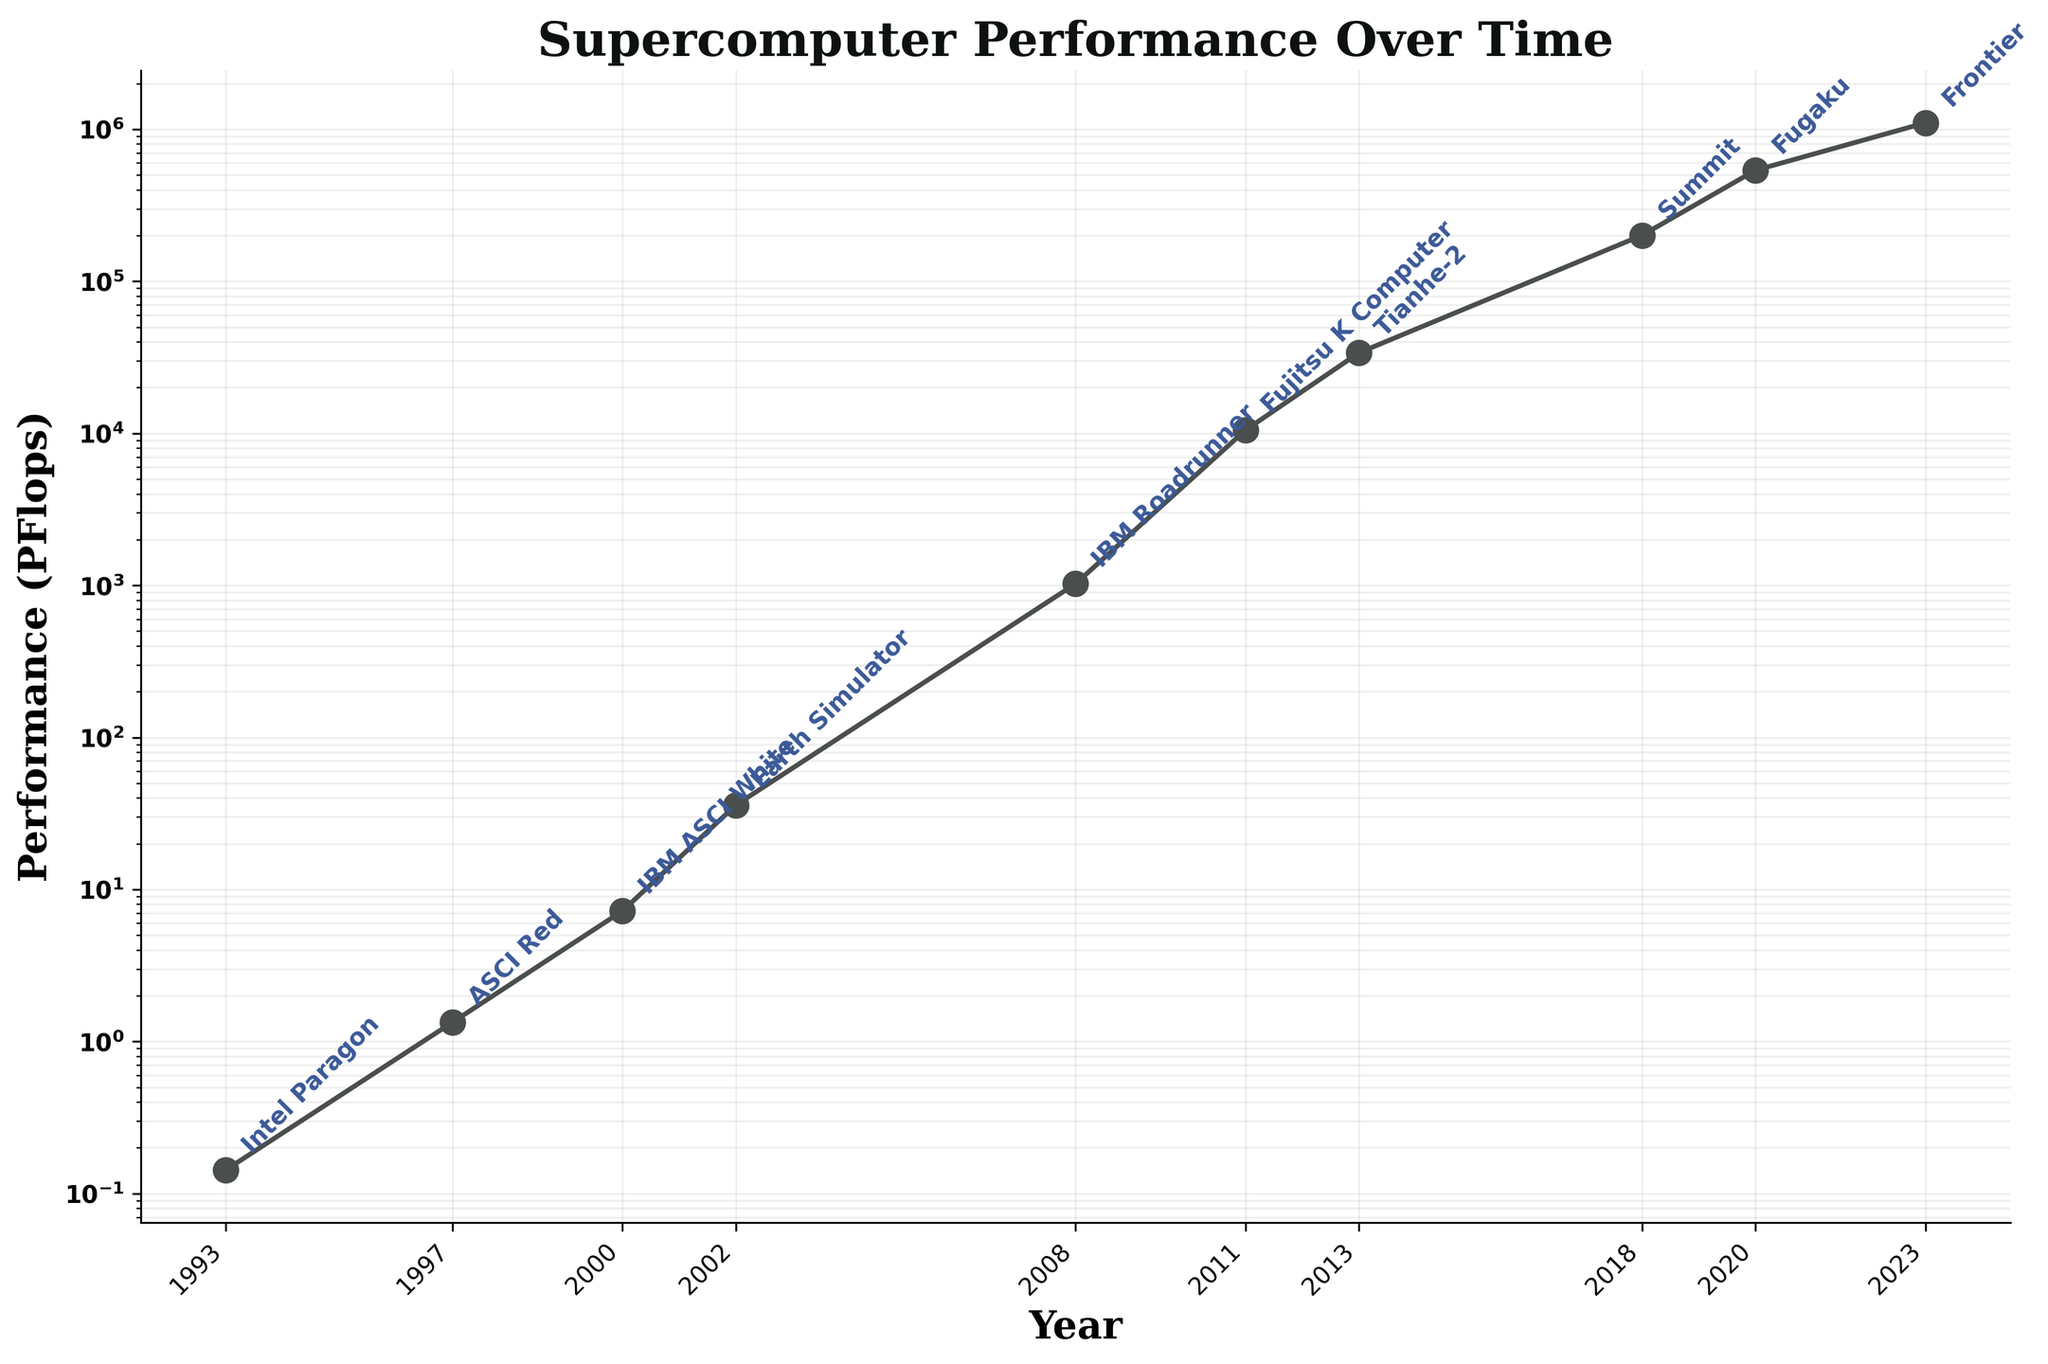How many data points are shown in the plot? To determine the number of data points, count the number of markers (circles) on the line plot. Here, each circle represents a year with its corresponding supercomputer performance. There are 10 circles in total.
Answer: 10 What is the title of the plot? The title of the plot is typically found at the top of the figure. Here, it reads "Supercomputer Performance Over Time".
Answer: Supercomputer Performance Over Time Which supercomputer had the lowest performance, and in which year was it introduced? To find the lowest performance, look for the data point that is at the lowest position on the y-axis. This corresponds to Intel Paragon in 1993.
Answer: Intel Paragon in 1993 What is the performance difference between Fujitsu K Computer and Tianhe-2? Check the values corresponding to Fujitsu K Computer (2011) and Tianhe-2 (2013). Subtract Fujitsu K Computer's performance from Tianhe-2's performance: 33862 - 10510 = 23352 PFlops.
Answer: 23352 PFlops By how much did the performance increase from Summit to Fugaku? Locate the points for Summit (2018) and Fugaku (2020). Subtract Summit's performance from Fugaku's: 537212 - 200795 = 336417 PFlops.
Answer: 336417 PFlops What is the average performance of all the supercomputers listed? Sum the performance values of all supercomputers and divide by the total number of supercomputers: (0.143 + 1.338 + 7.226 + 35.86 + 1026 + 10510 + 33862 + 200795 + 537212 + 1102000) / 10 = 190649.663 PFlops.
Answer: 190649.663 PFlops Which year saw the biggest advancement in supercomputer performance? To find the biggest jump, calculate the difference in performance between each consecutive year, then find the maximum difference. The largest increase is from 2020 (Fugaku) to 2023 (Frontier): 1102000 - 537212 = 564788 PFlops.
Answer: 2020 to 2023 How does the performance change from 1993 to 2023 compare to the change from 2018 to 2023? Calculate the performance changes: 2023 (Frontier) - 1993 (Intel Paragon): 1102000 - 0.143 ≈ 1102000 and 2023 (Frontier) - 2018 (Summit): 1102000 - 200795 = 901205 PFlops. The change from 1993 to 2023 is significantly larger than from 2018 to 2023.
Answer: Greater from 1993 to 2023 Which supercomputer marked the first significant leap above 10,000 PFlops? Identify the first data point that exceeds 10,000 PFlops. This corresponds to the Fujitsu K Computer in 2011.
Answer: Fujitsu K Computer 